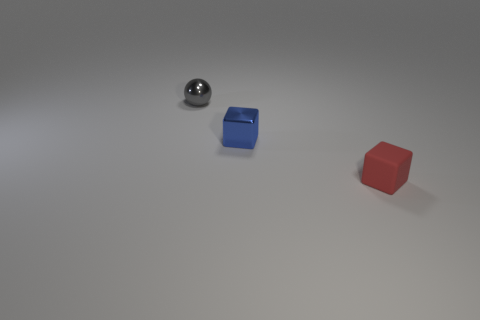What color is the ball that is the same size as the blue metal block?
Your answer should be compact. Gray. What number of metal objects have the same shape as the matte thing?
Make the answer very short. 1. What is the color of the sphere behind the blue metal cube?
Provide a succinct answer. Gray. How many metal objects are gray spheres or tiny blocks?
Provide a succinct answer. 2. How many matte cubes are the same size as the blue shiny block?
Make the answer very short. 1. What is the color of the small thing that is behind the rubber object and on the right side of the tiny gray thing?
Make the answer very short. Blue. What number of objects are either gray metal spheres or metallic cubes?
Your answer should be compact. 2. What number of small objects are either red rubber things or cubes?
Your answer should be compact. 2. Are there any other things that have the same color as the rubber block?
Offer a very short reply. No. What is the size of the thing that is both on the right side of the gray metal thing and behind the red matte cube?
Make the answer very short. Small. 